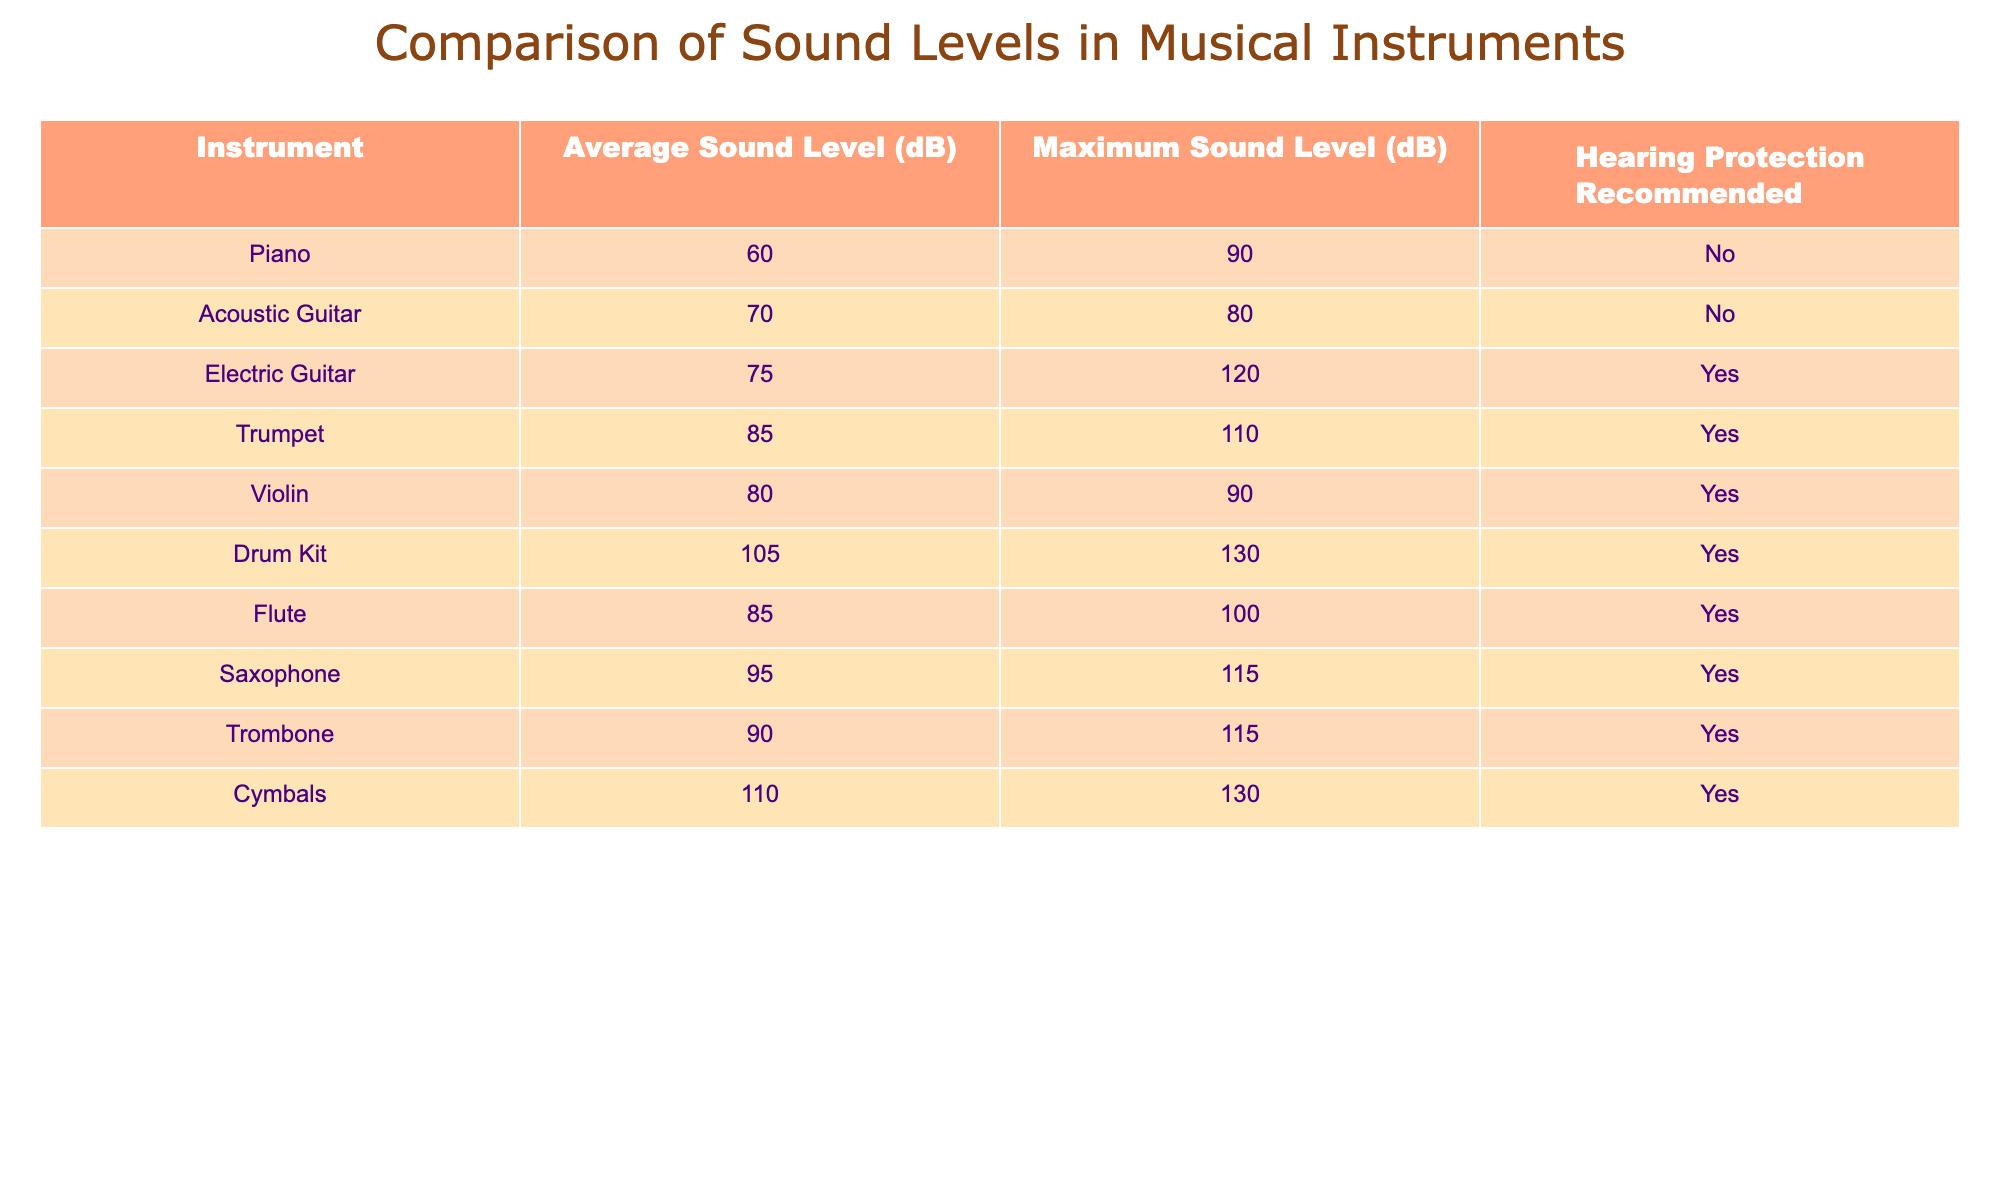What is the average sound level of the electric guitar? The table shows the average sound level for the electric guitar as 75 dB.
Answer: 75 dB How many instruments have a maximum sound level above 100 dB? The instruments with a maximum sound level above 100 dB are the drum kit (130 dB), cymbals (130 dB), and electric guitar (120 dB), making it a total of three instruments.
Answer: 3 Is hearing protection recommended for the piano? The table indicates that hearing protection is not recommended for the piano.
Answer: No What is the difference between the maximum sound levels of the drum kit and the trumpet? The drum kit has a maximum sound level of 130 dB, while the trumpet has a maximum sound level of 110 dB. Therefore, the difference is 130 dB - 110 dB = 20 dB.
Answer: 20 dB Which instrument has the highest average sound level? The table shows that the cymbals have the highest average sound level at 110 dB.
Answer: 110 dB Are there more instruments that require hearing protection than those that do not? There are six instruments that require hearing protection (electric guitar, trumpet, violin, drum kit, flute, saxophone, trombone, and cymbals) and only two that do not (piano and acoustic guitar). Thus, yes, there are more instruments that require hearing protection.
Answer: Yes What is the average of the maximum sound levels for all instruments listed? The maximum sound levels listed are 90, 80, 120, 110, 90, 130, 100, 115, 115, and 130 dB. Adding them gives 1,200 dB, and since there are 10 instruments, the average is 1,200 dB / 10 = 120 dB.
Answer: 120 dB Which two instruments have the closest average sound levels? Evaluating the average sound levels reveals that the acoustic guitar (70 dB) and the electric guitar (75 dB) have the closest average sound levels, differing by only 5 dB.
Answer: Acoustic guitar and electric guitar What is the highest sound level that does not recommend hearing protection? The acoustic guitar has a maximum sound level of 80 dB, which is the highest level listed in the table that does not require hearing protection.
Answer: 80 dB 